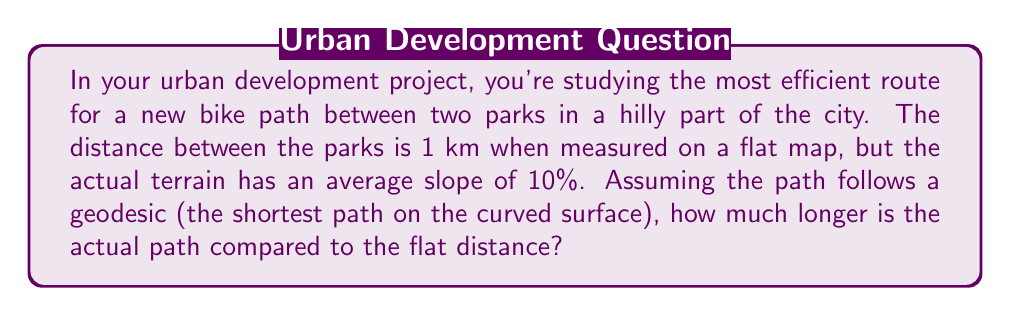Solve this math problem. Let's approach this step-by-step:

1) First, we need to understand what a geodesic is. In differential geometry, a geodesic is the shortest path between two points on a curved surface. In this case, our surface is the hilly terrain of the city.

2) We're given two key pieces of information:
   - The flat distance between the parks is 1 km
   - The average slope is 10%

3) A 10% slope means that for every 100 meters horizontally, there's a 10-meter change in elevation. We can represent this as a right triangle.

4) Let's consider the path as a right triangle:
   - The base (flat distance) is 1000 m
   - The height (elevation change) is 10% of 1000 m, which is 100 m

5) We can use the Pythagorean theorem to calculate the actual path length:

   $$c = \sqrt{a^2 + b^2}$$

   Where:
   $c$ is the actual path length
   $a$ is the flat distance (1000 m)
   $b$ is the elevation change (100 m)

6) Plugging in the values:

   $$c = \sqrt{1000^2 + 100^2} = \sqrt{1,010,000} \approx 1004.99 \text{ m}$$

7) The difference between the actual path and the flat distance is:

   $$1004.99 - 1000 = 4.99 \text{ m}$$

8) To express this as a percentage:

   $$\frac{4.99}{1000} \times 100\% \approx 0.499\%$$
Answer: The actual path is approximately 4.99 m or 0.499% longer than the flat distance. 